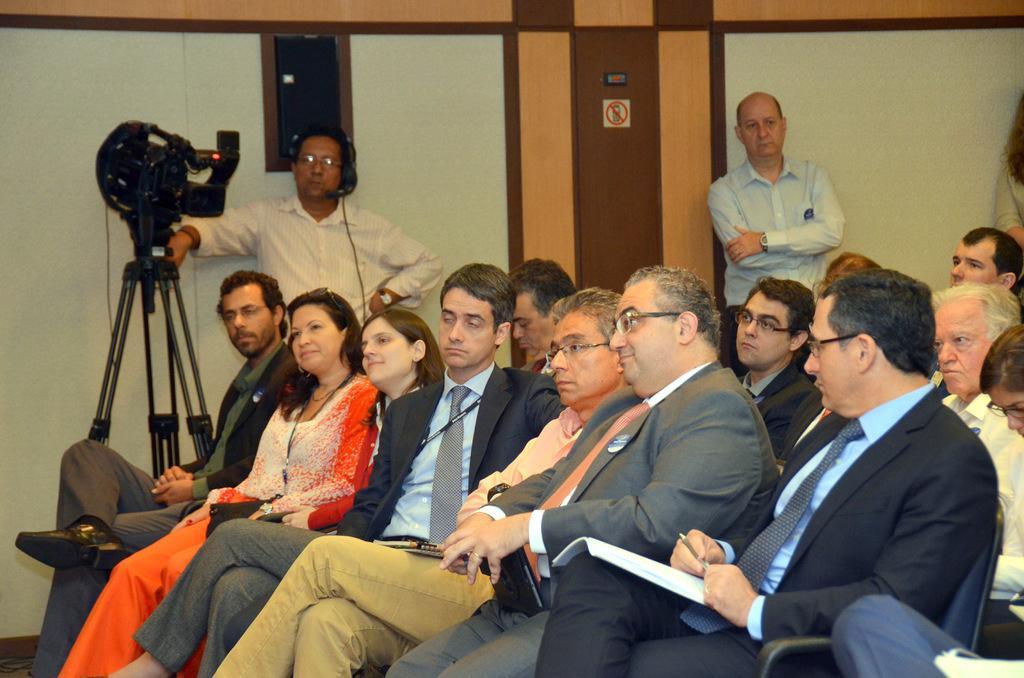Describe this image in one or two sentences. This picture is taken inside the room. In this image, we can see a group of people sitting on the chair. In the background, we can see two people are standing, we can also see a man standing and holding a camera in his hand. In the background, we can see a wall and a door. 